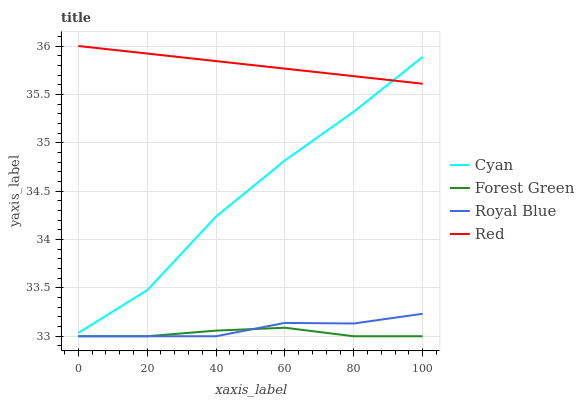Does Red have the minimum area under the curve?
Answer yes or no. No. Does Forest Green have the maximum area under the curve?
Answer yes or no. No. Is Forest Green the smoothest?
Answer yes or no. No. Is Forest Green the roughest?
Answer yes or no. No. Does Red have the lowest value?
Answer yes or no. No. Does Forest Green have the highest value?
Answer yes or no. No. Is Royal Blue less than Cyan?
Answer yes or no. Yes. Is Red greater than Forest Green?
Answer yes or no. Yes. Does Royal Blue intersect Cyan?
Answer yes or no. No. 